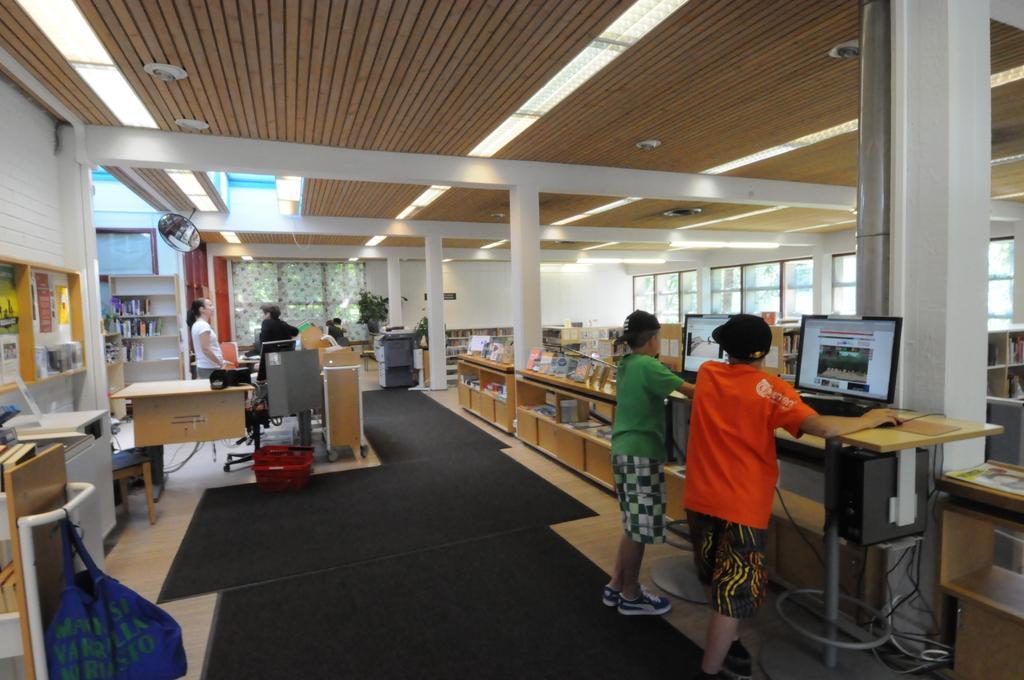Could you give a brief overview of what you see in this image? In the left a woman is standing there is a light at the top. In the right two men are standing and playing games in a system. 